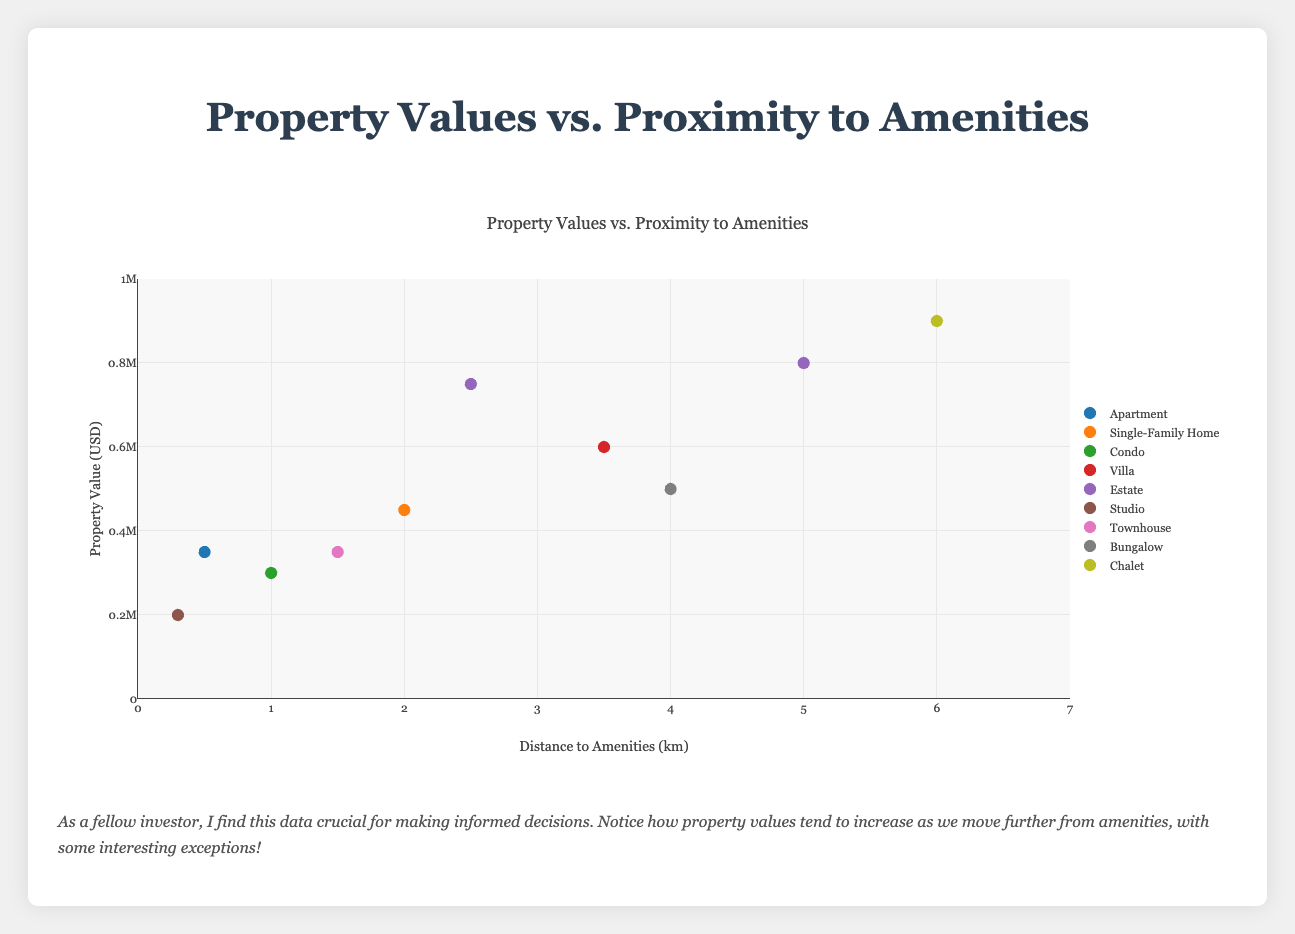What is the title of the figure? The title of the figure is usually located at the top. In this case, it is displayed prominently in large font.
Answer: Property Values vs. Proximity to Amenities Which property type has the highest property value? By looking at the y-axis (Property Value in USD) and identifying the data point with the highest position, we can see that "Mountain Chalets" have the highest property value.
Answer: Chalet How many property types are displayed in the figure? Each property type is indicated by a unique marker and listed in the legend. By counting the unique markers, we observe there are seven property types.
Answer: Seven What is the average property value of Estates? To find the average property value of Estates, we sum their values: 800,000 (Countryside Estates) + 750,000 (Gated Community Estates) = 1,550,000 USD. Then, divide by the number of Estates, which is 2: 1,550,000 / 2.
Answer: 775,000 USD Which property type is closest to amenities? By checking the x-axis (Distance to Amenities in km) and identifying the data point closest to 0, we see that "City Center Studios" is the nearest with 0.3 km.
Answer: Studio Does a longer distance from amenities generally correlate with higher property values? By examining the overall trend of data points from left (shorter distance to amenities) to right (longer distance to amenities), we notice that property values do tend to increase with longer distances. However, there are significant exceptions.
Answer: Yes, with exceptions Which property type is located further from amenities, "Beachside Bungalows" or "Urban Condos"? By comparing their positions on the x-axis, "Beachside Bungalows" (4.0 km) are located further from amenities than "Urban Condos" (1.0 km).
Answer: Beachside Bungalows Are there any property types with equal property values? By checking the y-axis (Property Value in USD) for overlapping points, we observe that "Downtown Apartments" and "Townhouse Complex" each have a property value of 350,000 USD.
Answer: Yes Which property has the highest value within 2 km proximity to amenities? By focusing on the points within 2 km on the x-axis and identifying the highest y-axis value among them, "Suburban Family Homes" has the highest value at 450,000 USD.
Answer: Suburban Family Homes Is there any property with a value less than 300,000 USD? By examining the y-axis for values below 300,000 USD, we find "City Center Studios" with a value of 200,000 USD fits this criterion.
Answer: Yes 